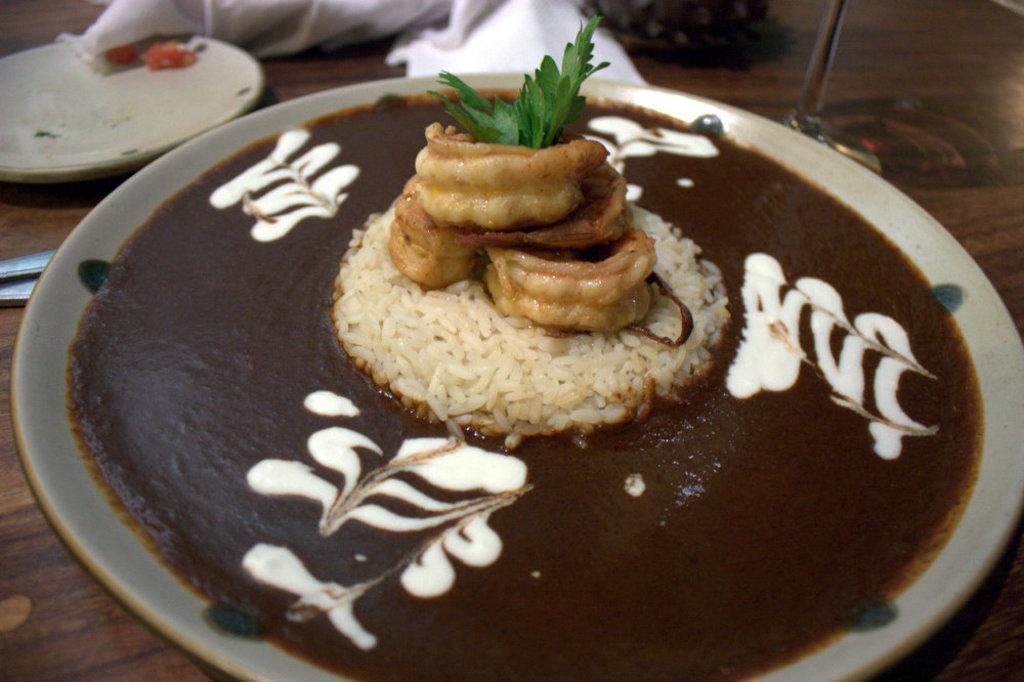Please provide a concise description of this image. In this image we can see a food item on a plate. The plate is on the wooden surface. At the top of the image, we can see a cloth, a plate and a glass. It seems like spoons on the left side of the image. 